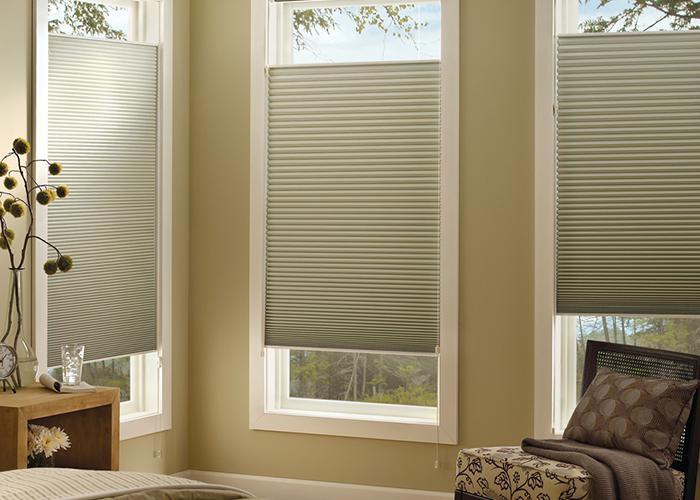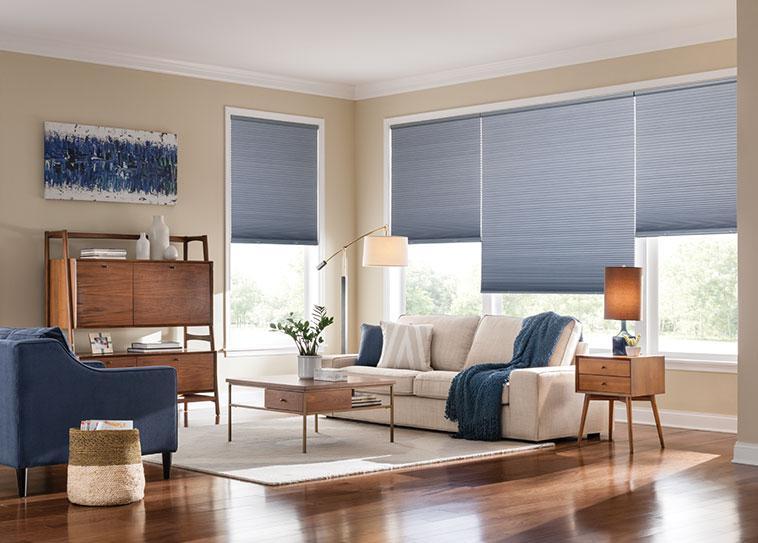The first image is the image on the left, the second image is the image on the right. For the images displayed, is the sentence "The left image shows three window screens on windows." factually correct? Answer yes or no. Yes. The first image is the image on the left, the second image is the image on the right. Evaluate the accuracy of this statement regarding the images: "The left and right image contains a total of seven blinds.". Is it true? Answer yes or no. Yes. 